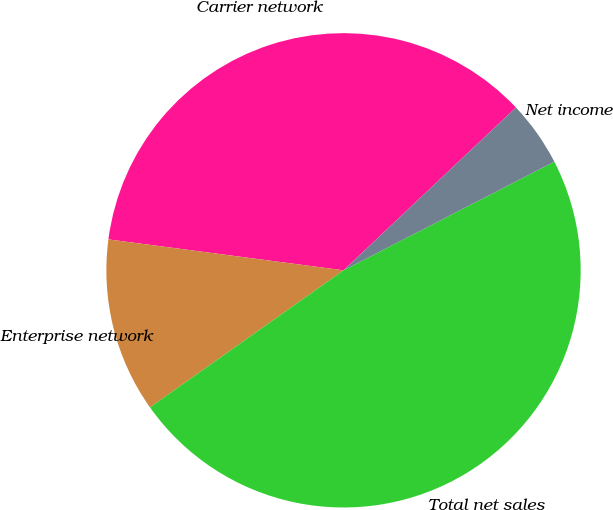<chart> <loc_0><loc_0><loc_500><loc_500><pie_chart><fcel>Carrier network<fcel>Enterprise network<fcel>Total net sales<fcel>Net income<nl><fcel>35.87%<fcel>11.89%<fcel>47.76%<fcel>4.47%<nl></chart> 